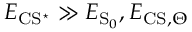<formula> <loc_0><loc_0><loc_500><loc_500>E _ { C S ^ { ^ { * } } } \gg E _ { { S } _ { 0 } } , E _ { C S , \Theta }</formula> 